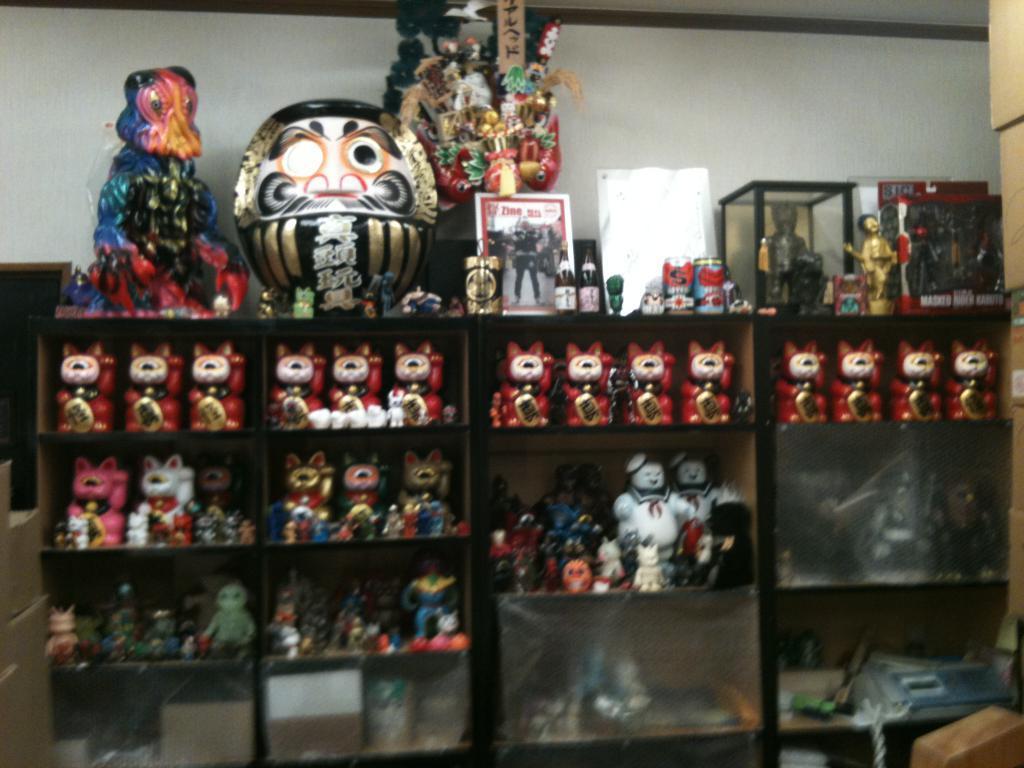Can you describe this image briefly? At the center of the image in the shelf there are many toys. At the back side there is a wall. 